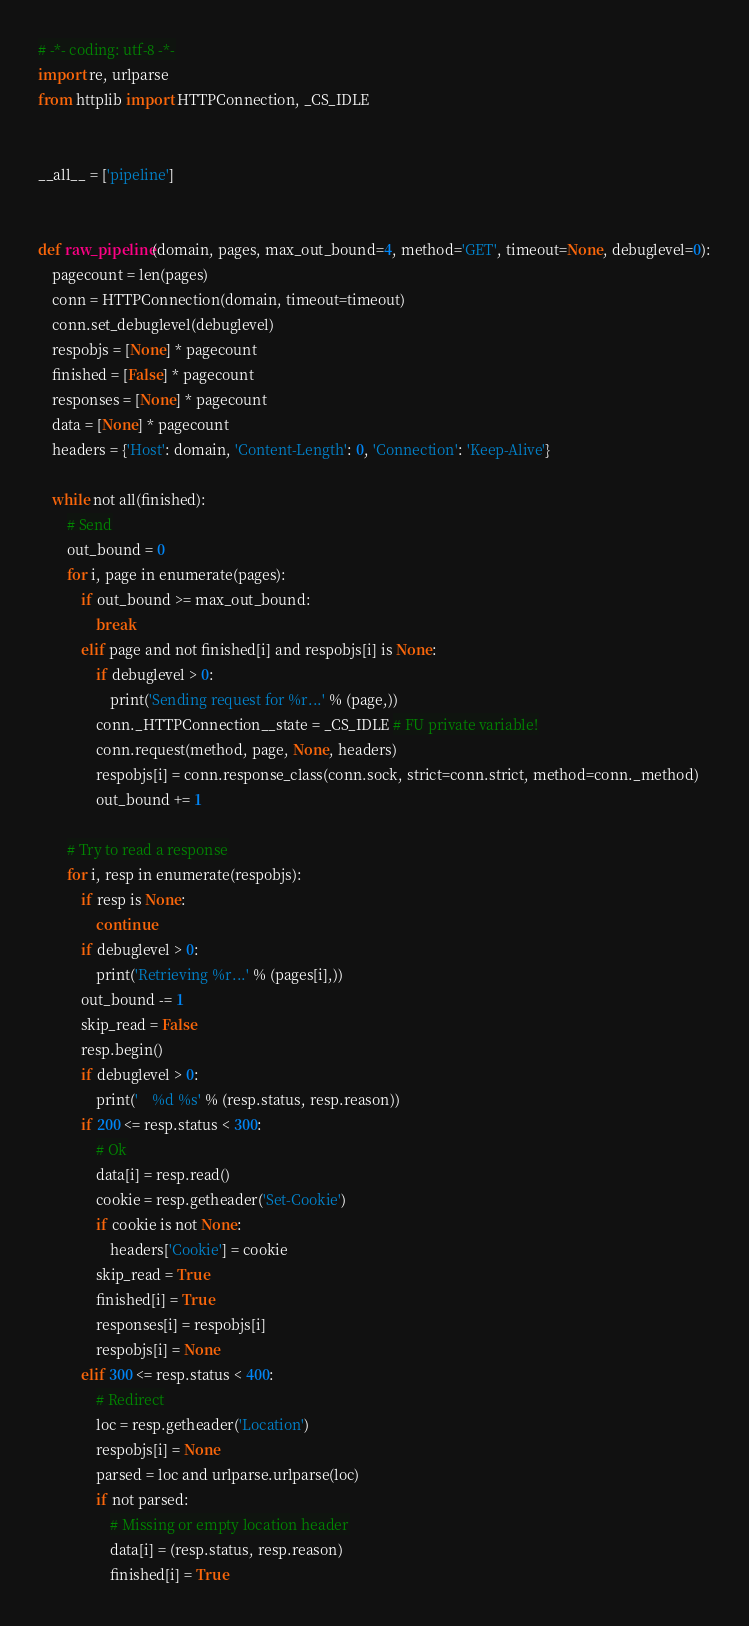<code> <loc_0><loc_0><loc_500><loc_500><_Python_># -*- coding: utf-8 -*-
import re, urlparse
from httplib import HTTPConnection, _CS_IDLE


__all__ = ['pipeline']


def raw_pipeline(domain, pages, max_out_bound=4, method='GET', timeout=None, debuglevel=0):
    pagecount = len(pages)
    conn = HTTPConnection(domain, timeout=timeout)
    conn.set_debuglevel(debuglevel)
    respobjs = [None] * pagecount
    finished = [False] * pagecount
    responses = [None] * pagecount
    data = [None] * pagecount
    headers = {'Host': domain, 'Content-Length': 0, 'Connection': 'Keep-Alive'}

    while not all(finished):
        # Send
        out_bound = 0
        for i, page in enumerate(pages):
            if out_bound >= max_out_bound:
                break
            elif page and not finished[i] and respobjs[i] is None:
                if debuglevel > 0:
                    print('Sending request for %r...' % (page,))
                conn._HTTPConnection__state = _CS_IDLE # FU private variable!
                conn.request(method, page, None, headers)
                respobjs[i] = conn.response_class(conn.sock, strict=conn.strict, method=conn._method)
                out_bound += 1

        # Try to read a response
        for i, resp in enumerate(respobjs):
            if resp is None:
                continue
            if debuglevel > 0:
                print('Retrieving %r...' % (pages[i],))
            out_bound -= 1
            skip_read = False
            resp.begin()
            if debuglevel > 0:
                print('    %d %s' % (resp.status, resp.reason))
            if 200 <= resp.status < 300:
                # Ok
                data[i] = resp.read()
                cookie = resp.getheader('Set-Cookie')
                if cookie is not None:
                    headers['Cookie'] = cookie
                skip_read = True
                finished[i] = True
                responses[i] = respobjs[i]
                respobjs[i] = None
            elif 300 <= resp.status < 400:
                # Redirect
                loc = resp.getheader('Location')
                respobjs[i] = None
                parsed = loc and urlparse.urlparse(loc)
                if not parsed:
                    # Missing or empty location header
                    data[i] = (resp.status, resp.reason)
                    finished[i] = True</code> 